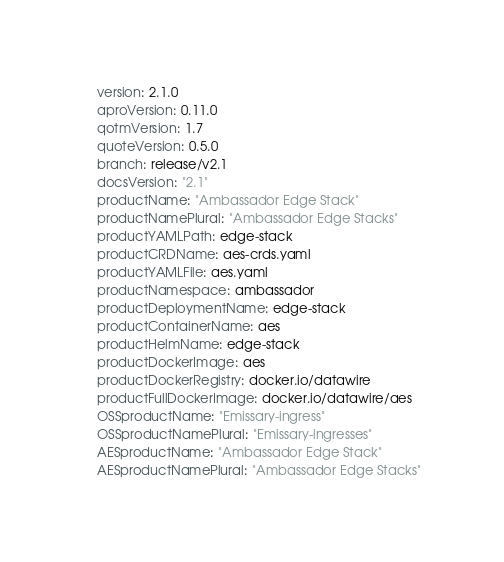Convert code to text. <code><loc_0><loc_0><loc_500><loc_500><_YAML_>version: 2.1.0
aproVersion: 0.11.0
qotmVersion: 1.7
quoteVersion: 0.5.0
branch: release/v2.1
docsVersion: "2.1"
productName: "Ambassador Edge Stack"
productNamePlural: "Ambassador Edge Stacks"
productYAMLPath: edge-stack
productCRDName: aes-crds.yaml
productYAMLFile: aes.yaml
productNamespace: ambassador
productDeploymentName: edge-stack
productContainerName: aes
productHelmName: edge-stack
productDockerImage: aes
productDockerRegistry: docker.io/datawire
productFullDockerImage: docker.io/datawire/aes
OSSproductName: "Emissary-ingress"
OSSproductNamePlural: "Emissary-ingresses"
AESproductName: "Ambassador Edge Stack"
AESproductNamePlural: "Ambassador Edge Stacks"
</code> 